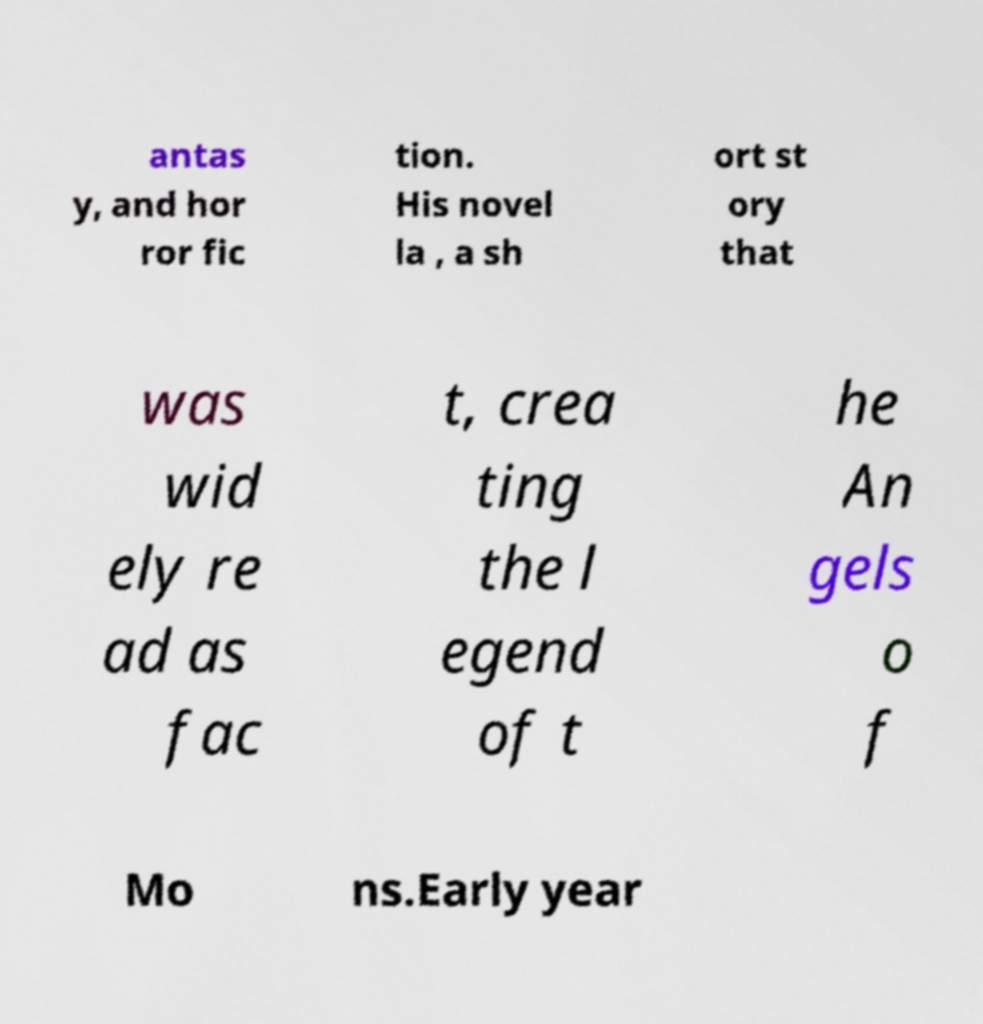Please read and relay the text visible in this image. What does it say? antas y, and hor ror fic tion. His novel la , a sh ort st ory that was wid ely re ad as fac t, crea ting the l egend of t he An gels o f Mo ns.Early year 